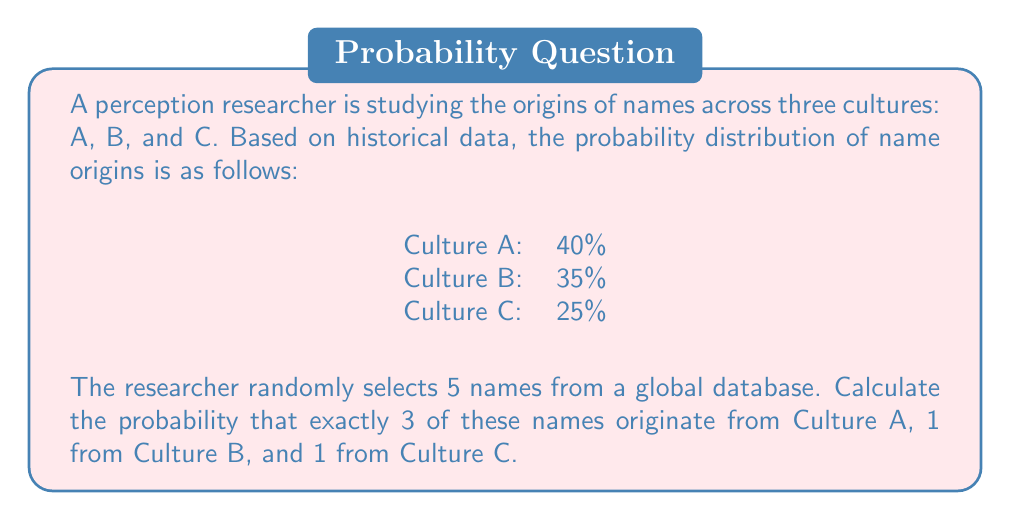Could you help me with this problem? To solve this problem, we need to use the multinomial distribution, which is an extension of the binomial distribution for more than two outcomes.

The probability mass function for the multinomial distribution is:

$$P(X_1 = x_1, X_2 = x_2, ..., X_k = x_k) = \frac{n!}{x_1! x_2! ... x_k!} p_1^{x_1} p_2^{x_2} ... p_k^{x_k}$$

Where:
$n$ is the total number of trials
$x_i$ is the number of occurrences of outcome $i$
$p_i$ is the probability of outcome $i$

In our case:
$n = 5$ (total names selected)
$x_1 = 3$ (names from Culture A)
$x_2 = 1$ (name from Culture B)
$x_3 = 1$ (name from Culture C)
$p_1 = 0.40$ (probability of Culture A)
$p_2 = 0.35$ (probability of Culture B)
$p_3 = 0.25$ (probability of Culture C)

Substituting these values into the formula:

$$P(X_1 = 3, X_2 = 1, X_3 = 1) = \frac{5!}{3! 1! 1!} (0.40)^3 (0.35)^1 (0.25)^1$$

Simplifying:

$$P(X_1 = 3, X_2 = 1, X_3 = 1) = \frac{5 \cdot 4}{2} \cdot 0.064 \cdot 0.35 \cdot 0.25$$

$$P(X_1 = 3, X_2 = 1, X_3 = 1) = 10 \cdot 0.064 \cdot 0.35 \cdot 0.25$$

$$P(X_1 = 3, X_2 = 1, X_3 = 1) = 0.056$$
Answer: The probability of selecting exactly 3 names from Culture A, 1 from Culture B, and 1 from Culture C out of 5 randomly selected names is approximately 0.056 or 5.6%. 